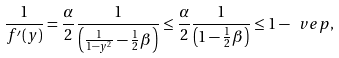<formula> <loc_0><loc_0><loc_500><loc_500>\frac { 1 } { f ^ { \prime } ( y ) } = \frac { \alpha } { 2 } \frac { 1 } { \left ( \frac { 1 } { 1 - y ^ { 2 } } - \frac { 1 } { 2 } \beta \right ) } \leq \frac { \alpha } { 2 } \frac { 1 } { \left ( 1 - \frac { 1 } { 2 } \beta \right ) } \leq 1 - \ v e p ,</formula> 